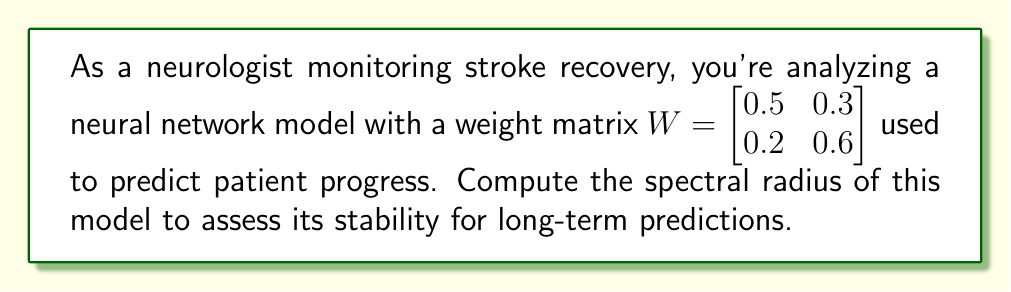Give your solution to this math problem. To compute the spectral radius of the neural network model, we follow these steps:

1) The spectral radius is defined as the largest absolute eigenvalue of the weight matrix $W$.

2) To find the eigenvalues, we solve the characteristic equation:
   $$\det(W - \lambda I) = 0$$

3) Expanding this:
   $$\begin{vmatrix} 
   0.5 - \lambda & 0.3 \\
   0.2 & 0.6 - \lambda
   \end{vmatrix} = 0$$

4) Calculating the determinant:
   $$(0.5 - \lambda)(0.6 - \lambda) - 0.3 \cdot 0.2 = 0$$
   $$\lambda^2 - 1.1\lambda + 0.24 = 0$$

5) Using the quadratic formula to solve for $\lambda$:
   $$\lambda = \frac{1.1 \pm \sqrt{1.1^2 - 4(0.24)}}{2}$$
   $$\lambda = \frac{1.1 \pm \sqrt{0.49}}{2}$$
   $$\lambda = \frac{1.1 \pm 0.7}{2}$$

6) This gives us two eigenvalues:
   $$\lambda_1 = \frac{1.1 + 0.7}{2} = 0.9$$
   $$\lambda_2 = \frac{1.1 - 0.7}{2} = 0.2$$

7) The spectral radius is the largest absolute value of these eigenvalues:
   $$\rho(W) = \max(|\lambda_1|, |\lambda_2|) = \max(0.9, 0.2) = 0.9$$
Answer: 0.9 